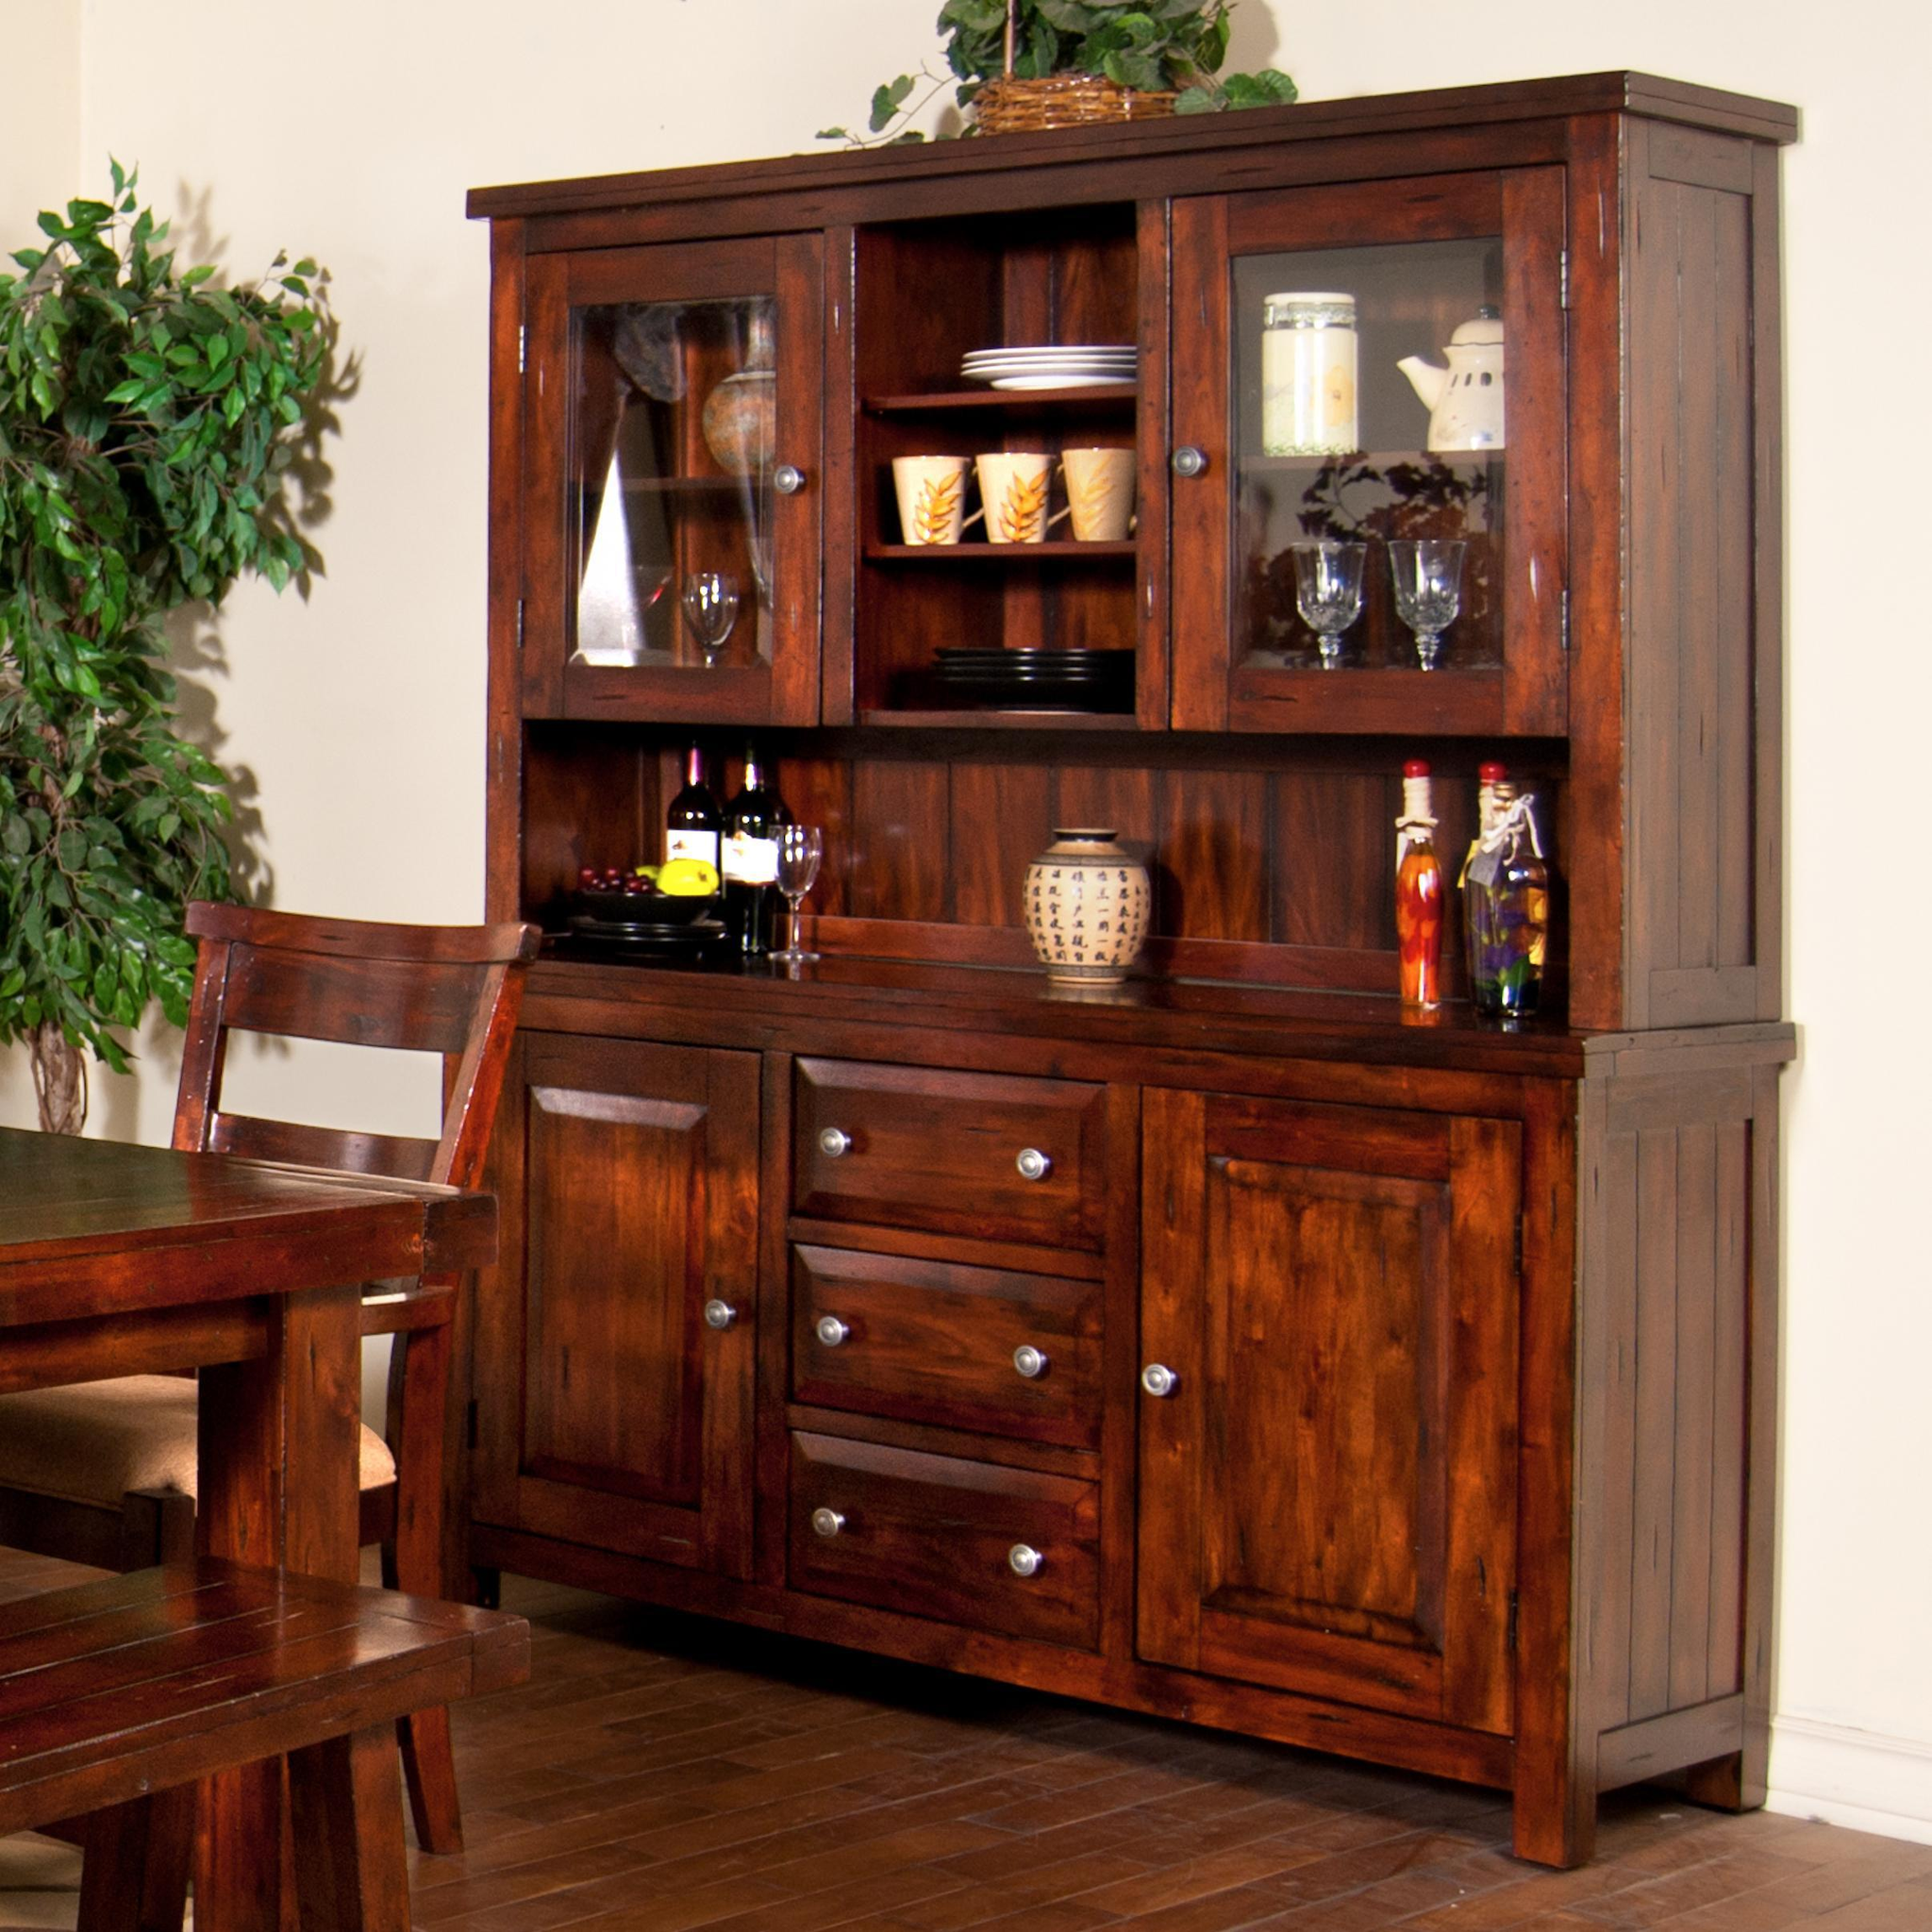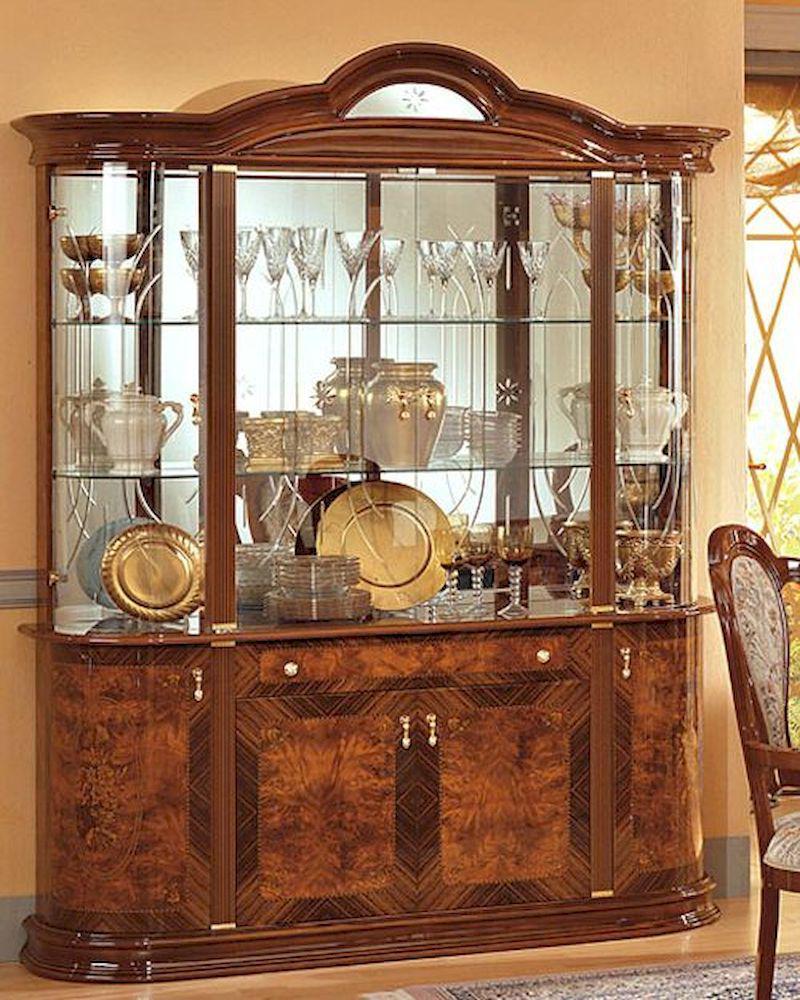The first image is the image on the left, the second image is the image on the right. Considering the images on both sides, is "A richly-colored brown cabinet has an arch shape at the center of the top and sits flush on the floor." valid? Answer yes or no. Yes. The first image is the image on the left, the second image is the image on the right. Given the left and right images, does the statement "There is at least one chair in every image." hold true? Answer yes or no. Yes. 